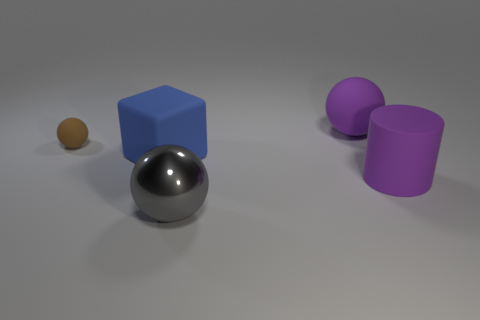Are there any other things that have the same material as the gray thing?
Give a very brief answer. No. Are any small metallic cubes visible?
Your answer should be compact. No. Does the object to the left of the big rubber block have the same material as the large gray sphere?
Make the answer very short. No. Are there any brown things that have the same shape as the large gray thing?
Ensure brevity in your answer.  Yes. Are there the same number of small brown spheres that are in front of the large gray metal sphere and small gray cylinders?
Make the answer very short. Yes. What is the material of the large sphere that is on the left side of the big purple rubber thing that is to the left of the large purple cylinder?
Your response must be concise. Metal. The blue matte object is what shape?
Your answer should be very brief. Cube. Is the number of balls behind the big rubber cylinder the same as the number of big metallic objects behind the big metal thing?
Give a very brief answer. No. There is a big ball that is behind the brown matte ball; is its color the same as the big ball that is in front of the small brown object?
Your answer should be compact. No. Are there more matte objects to the right of the purple cylinder than small cyan rubber cylinders?
Your answer should be very brief. No. 